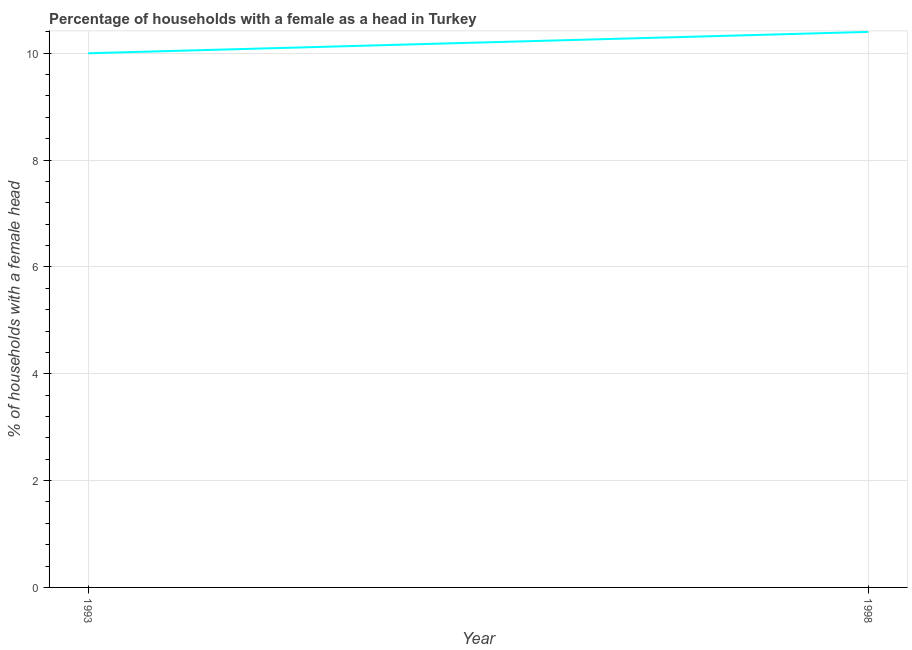Across all years, what is the minimum number of female supervised households?
Provide a succinct answer. 10. In which year was the number of female supervised households minimum?
Offer a very short reply. 1993. What is the sum of the number of female supervised households?
Keep it short and to the point. 20.4. What is the difference between the number of female supervised households in 1993 and 1998?
Offer a terse response. -0.4. What is the ratio of the number of female supervised households in 1993 to that in 1998?
Give a very brief answer. 0.96. Is the number of female supervised households in 1993 less than that in 1998?
Offer a very short reply. Yes. In how many years, is the number of female supervised households greater than the average number of female supervised households taken over all years?
Offer a very short reply. 1. Does the number of female supervised households monotonically increase over the years?
Your answer should be very brief. Yes. How many lines are there?
Your response must be concise. 1. How many years are there in the graph?
Keep it short and to the point. 2. Are the values on the major ticks of Y-axis written in scientific E-notation?
Your response must be concise. No. Does the graph contain grids?
Offer a terse response. Yes. What is the title of the graph?
Your response must be concise. Percentage of households with a female as a head in Turkey. What is the label or title of the X-axis?
Give a very brief answer. Year. What is the label or title of the Y-axis?
Make the answer very short. % of households with a female head. What is the % of households with a female head in 1993?
Your response must be concise. 10. What is the % of households with a female head of 1998?
Your response must be concise. 10.4. 